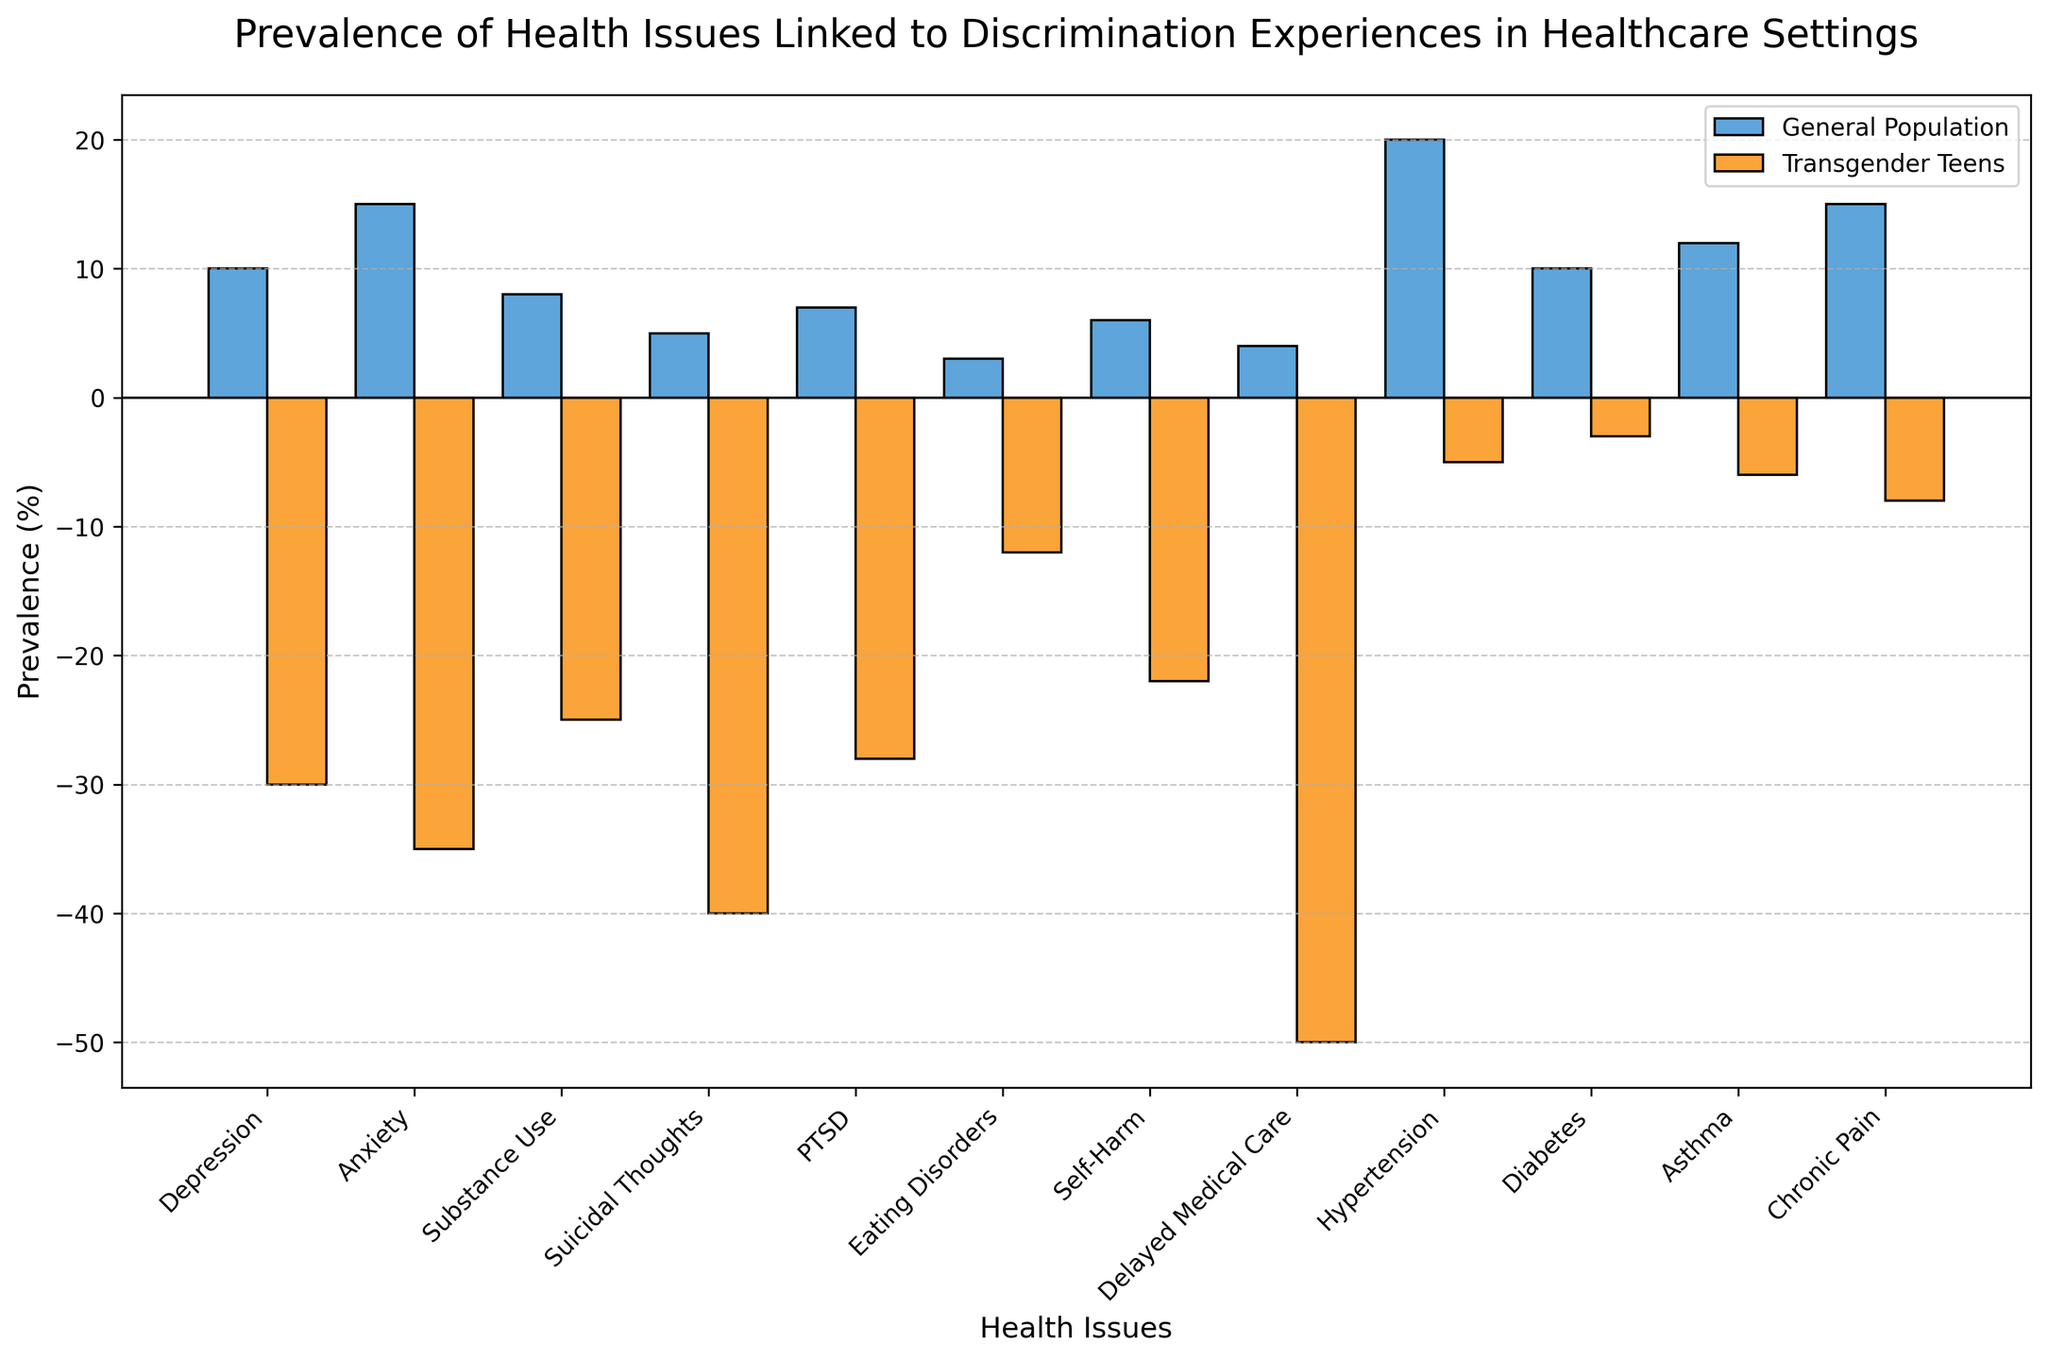What health issue shows the largest difference in prevalence between transgender teens and the general population? To identify the largest difference, we subtract each health issue value for the general population from the corresponding value for transgender teens. The largest negative difference indicates the greatest disparity. The differences are: Depression (-40%), Anxiety (-50%), Substance Use (-33%), Suicidal Thoughts (-45%), PTSD (-35%), Eating Disorders (-15%), Self-Harm (-28%), Delayed Medical Care (-54%), Hypertension (-25%), Diabetes (-13%), Asthma (-18%), Chronic Pain (-23%). The largest difference is Delayed Medical Care (-54%).
Answer: Delayed Medical Care Which group has a higher prevalence of depression? Compare the prevalence of depression between the general population and transgender teens. The general population has 10% while transgender teens have -30%. Since -30% is a larger negative value, it indicates a higher prevalence for transgender teens.
Answer: Transgender Teens What is the sum of the prevalence values of Depression and Anxiety for the transgender teen group? Identify the values for Depression (-30%) and Anxiety (-35%) for transgender teens, then add them together. The sum is -30 + (-35) = -65%.
Answer: -65% Which health issue has a prevalence close to zero for transgender teens? Look at the values for transgender teens to find the one closest to zero. Values include Depression (-30%), Anxiety (-35%), Substance Use (-25%), Suicidal Thoughts (-40%), PTSD (-28%), Eating Disorders (-12%), Self-Harm (-22%), Delayed Medical Care (-50%), Hypertension (-5%), Diabetes (-3%), Asthma (-6%), Chronic Pain (-8%). The closest value to zero is Diabetes (-3%).
Answer: Diabetes Among the following health issues: Chronic Pain, Anxiety, and Asthma, which has the lowest prevalence in the general population and in transgender teens? Compare Chronic Pain (15%), Anxiety (15%), and Asthma (12%) for the general population. The lowest value is Asthma (12%). Compare Chronic Pain (-8%), Anxiety (-35%), and Asthma (-6%) for transgender teens. The lowest value is Anxiety (-35%).
Answer: Asthma (General Population), Anxiety (Transgender Teens) For which health issue is the prevalence highest among the general population? Observe the values for the general population: Depression (10%), Anxiety (15%), Substance Use (8%), Suicidal Thoughts (5%), PTSD (7%), Eating Disorders (3%), Self-Harm (6%), Delayed Medical Care (4%), Hypertension (20%), Diabetes (10%), Asthma (12%), Chronic Pain (15%). The highest value is Hypertension (20%).
Answer: Hypertension How does the prevalence of PTSD among transgender teens compare to the general population? View the values for PTSD: general population is 7%, transgender teens is -28%. Transgender teens have a much higher prevalence as indicated by the larger negative value.
Answer: Transgender Teens What is the average prevalence of Anxiety and Self-Harm among transgender teens? Values are Anxiety (-35%) and Self-Harm (-22%). To find the average, sum them: -35 + (-22) = -57, and then divide by 2. (-57) / 2 = -28.5%.
Answer: -28.5% What is the proportion of transgender teens experiencing delayed medical care compared to the general population? Transgender teens have a prevalence of -50% for delayed medical care, while the general population is 4%. To find the proportion, divide the value for transgender teens by the value for the general population: -50 / 4 = -12.5.
Answer: -12.5 